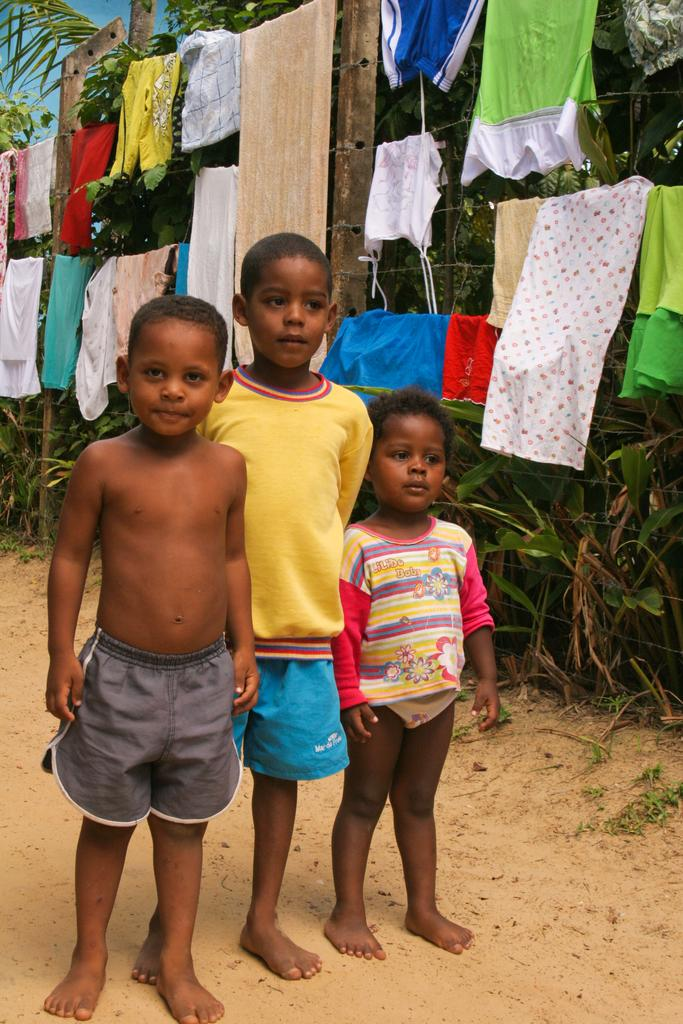How many kids are visible in the image? There are three kids standing on the ground in the image. What can be seen in the background of the image? Clothes hanging on ropes and plants are visible in the background of the image. Are there any other objects or features in the background? Yes, there are other unspecified objects in the background. What type of chess pieces can be seen on the ground near the kids? There are no chess pieces visible in the image; it only features three kids standing on the ground and objects in the background. 